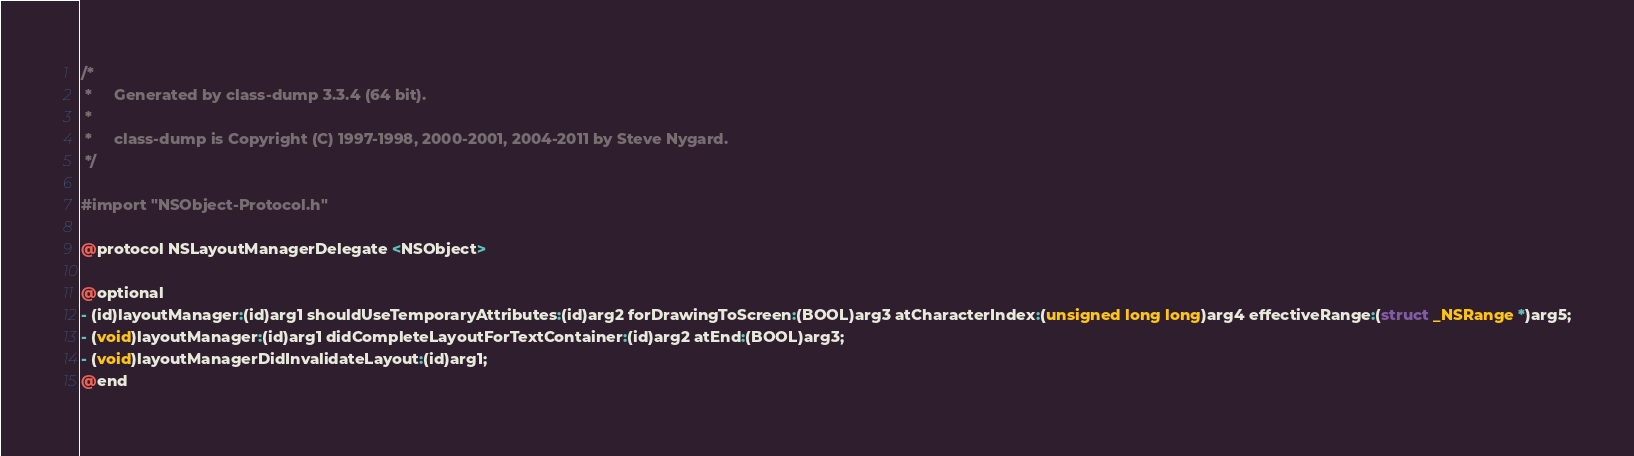<code> <loc_0><loc_0><loc_500><loc_500><_C_>/*
 *     Generated by class-dump 3.3.4 (64 bit).
 *
 *     class-dump is Copyright (C) 1997-1998, 2000-2001, 2004-2011 by Steve Nygard.
 */

#import "NSObject-Protocol.h"

@protocol NSLayoutManagerDelegate <NSObject>

@optional
- (id)layoutManager:(id)arg1 shouldUseTemporaryAttributes:(id)arg2 forDrawingToScreen:(BOOL)arg3 atCharacterIndex:(unsigned long long)arg4 effectiveRange:(struct _NSRange *)arg5;
- (void)layoutManager:(id)arg1 didCompleteLayoutForTextContainer:(id)arg2 atEnd:(BOOL)arg3;
- (void)layoutManagerDidInvalidateLayout:(id)arg1;
@end

</code> 